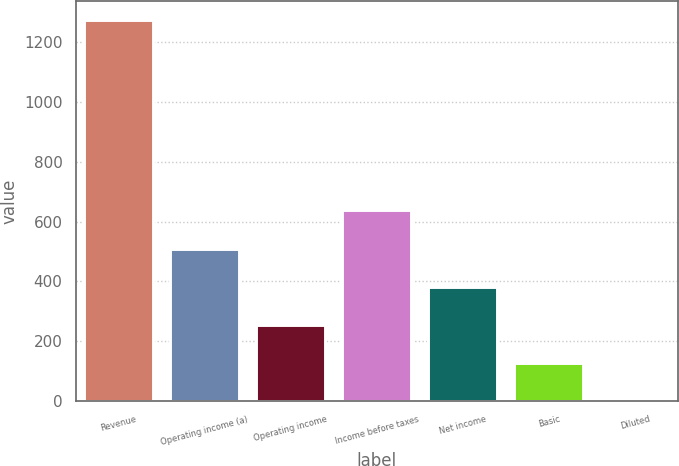<chart> <loc_0><loc_0><loc_500><loc_500><bar_chart><fcel>Revenue<fcel>Operating income (a)<fcel>Operating income<fcel>Income before taxes<fcel>Net income<fcel>Basic<fcel>Diluted<nl><fcel>1273.4<fcel>509.82<fcel>255.28<fcel>637.09<fcel>382.55<fcel>128.01<fcel>0.74<nl></chart> 